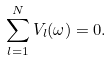<formula> <loc_0><loc_0><loc_500><loc_500>\sum _ { l = 1 } ^ { N } V _ { l } ( \omega ) = 0 .</formula> 